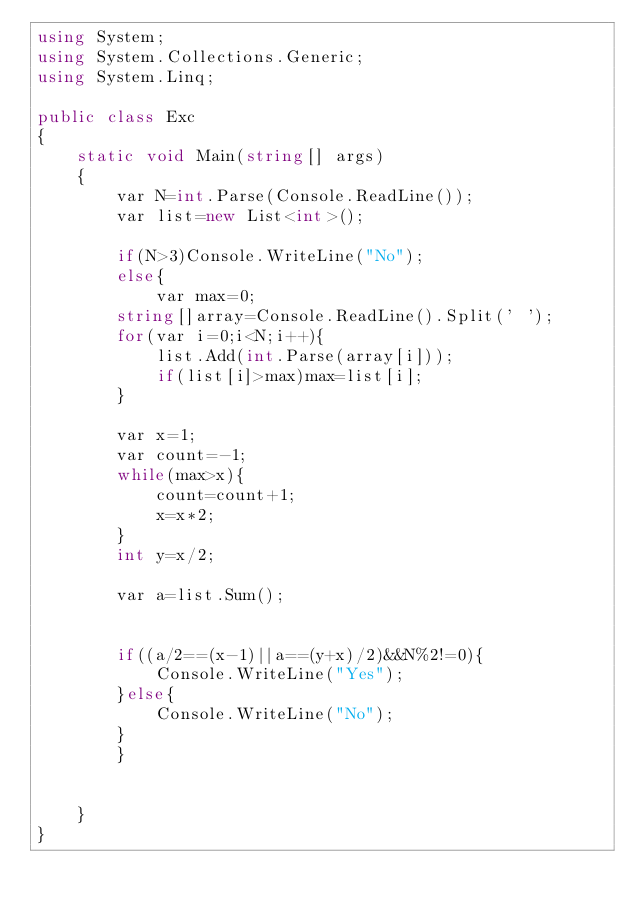<code> <loc_0><loc_0><loc_500><loc_500><_C#_>using System;
using System.Collections.Generic;
using System.Linq;

public class Exc
{
    static void Main(string[] args)
    {
        var N=int.Parse(Console.ReadLine());
        var list=new List<int>();
        
        if(N>3)Console.WriteLine("No");
        else{
            var max=0;
        string[]array=Console.ReadLine().Split(' ');
        for(var i=0;i<N;i++){
            list.Add(int.Parse(array[i]));
            if(list[i]>max)max=list[i];
        }
        
        var x=1;
        var count=-1;
        while(max>x){
            count=count+1;
            x=x*2;
        }
        int y=x/2;
        
        var a=list.Sum();
        
        
        if((a/2==(x-1)||a==(y+x)/2)&&N%2!=0){
            Console.WriteLine("Yes");
        }else{
            Console.WriteLine("No");
        }
        }
        
        
    }
}</code> 